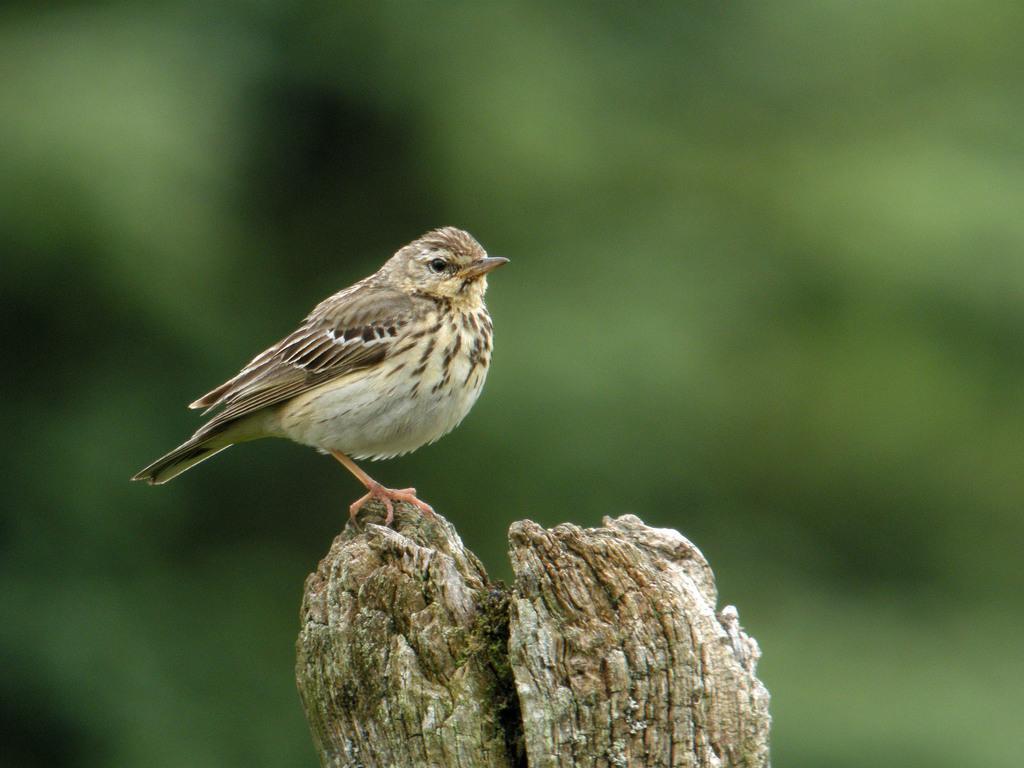Can you describe this image briefly? There is one bird on a wooden object as we can see in at the bottom of this image. 